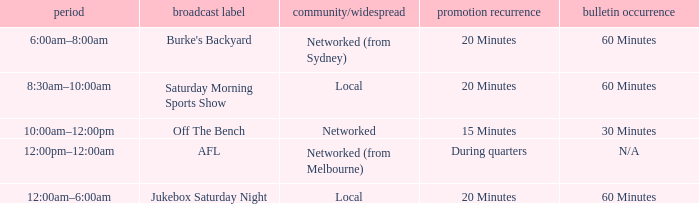What is the local/network with an Ad frequency of 15 minutes? Networked. 